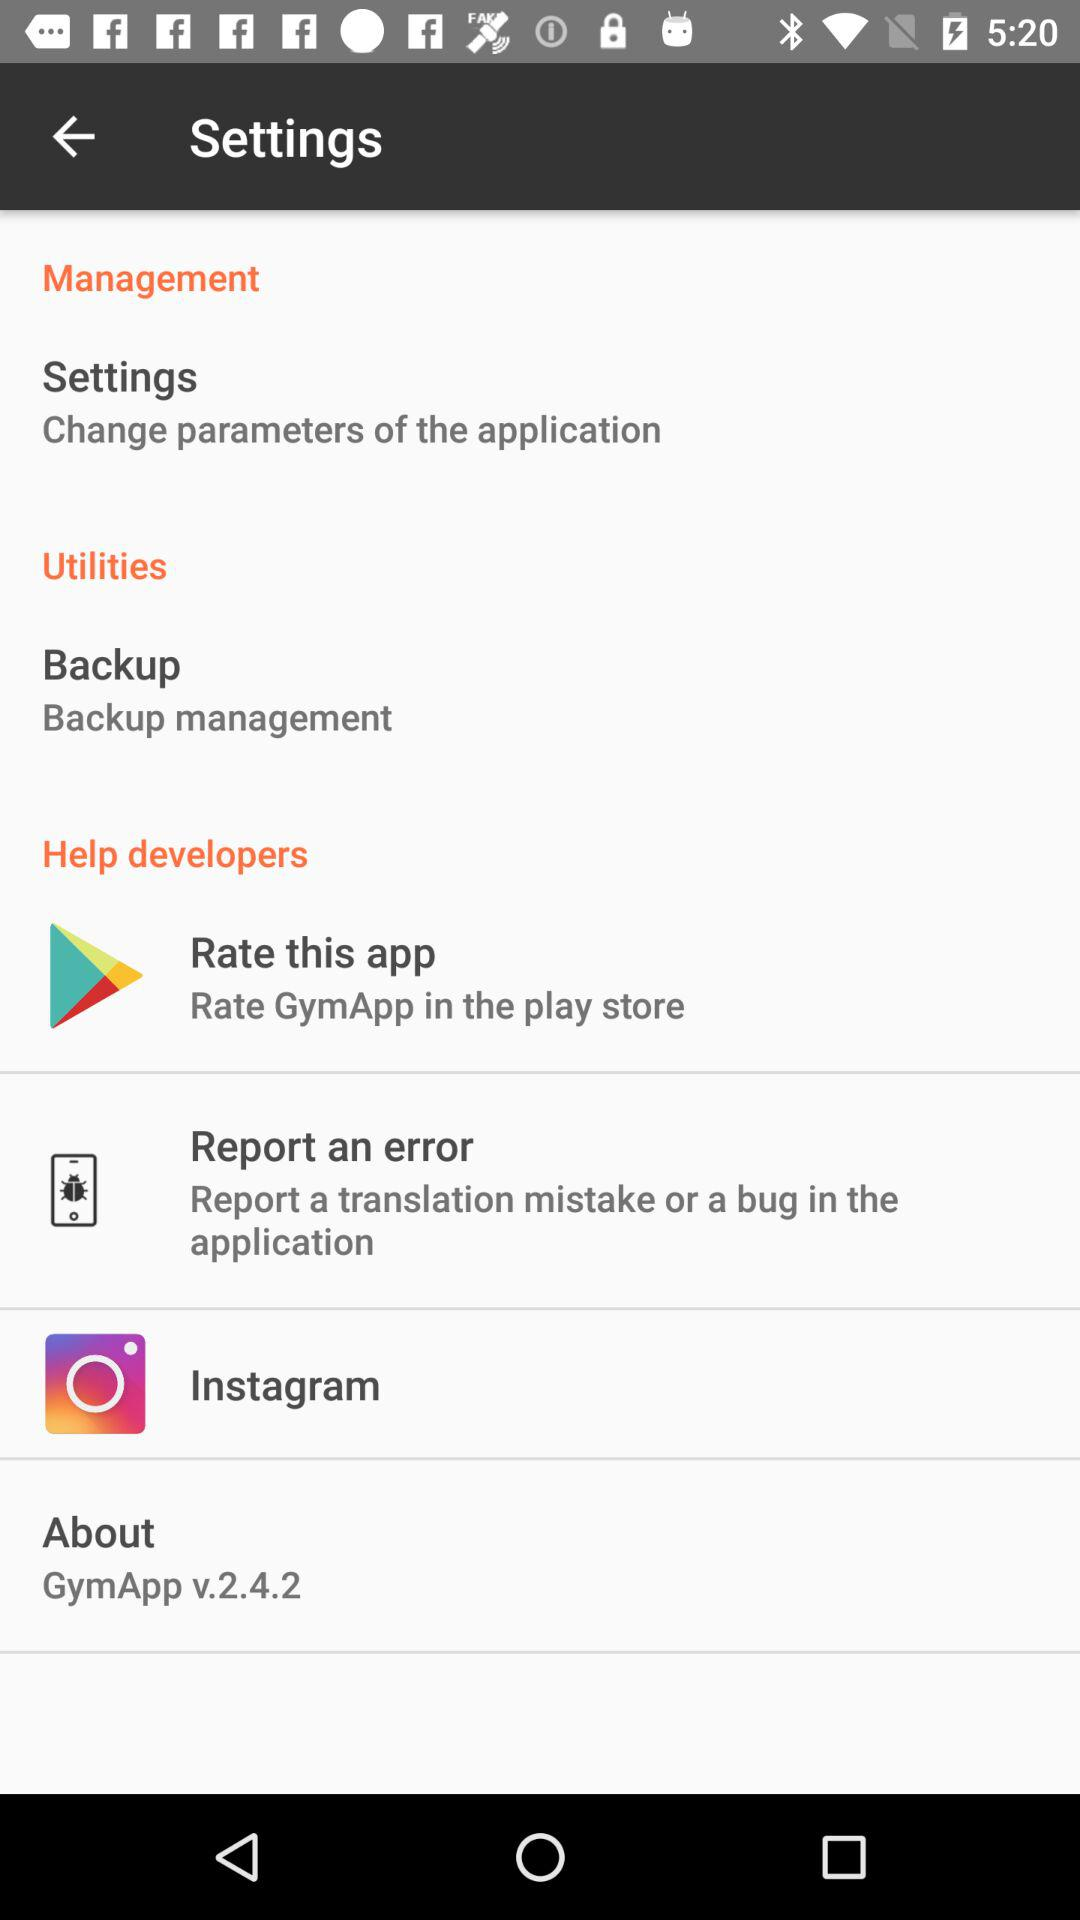What is the version of the "GymApp"? The version is v.2.4.2. 